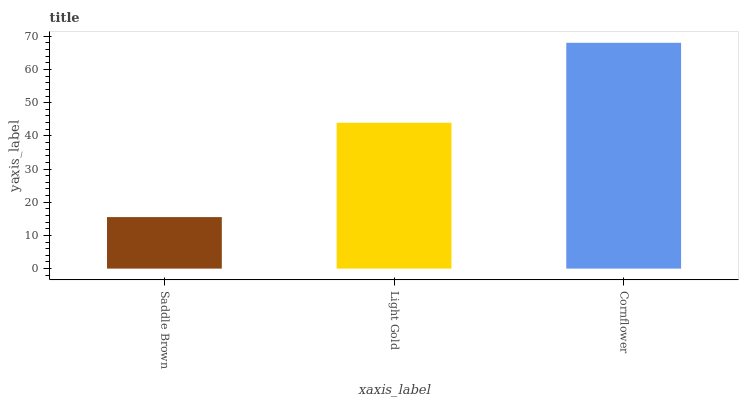Is Saddle Brown the minimum?
Answer yes or no. Yes. Is Cornflower the maximum?
Answer yes or no. Yes. Is Light Gold the minimum?
Answer yes or no. No. Is Light Gold the maximum?
Answer yes or no. No. Is Light Gold greater than Saddle Brown?
Answer yes or no. Yes. Is Saddle Brown less than Light Gold?
Answer yes or no. Yes. Is Saddle Brown greater than Light Gold?
Answer yes or no. No. Is Light Gold less than Saddle Brown?
Answer yes or no. No. Is Light Gold the high median?
Answer yes or no. Yes. Is Light Gold the low median?
Answer yes or no. Yes. Is Saddle Brown the high median?
Answer yes or no. No. Is Cornflower the low median?
Answer yes or no. No. 